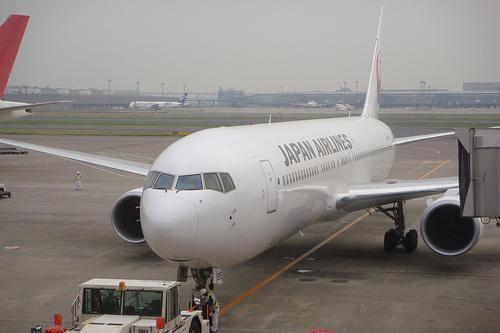How many planes are in the background?
Give a very brief answer. 1. 